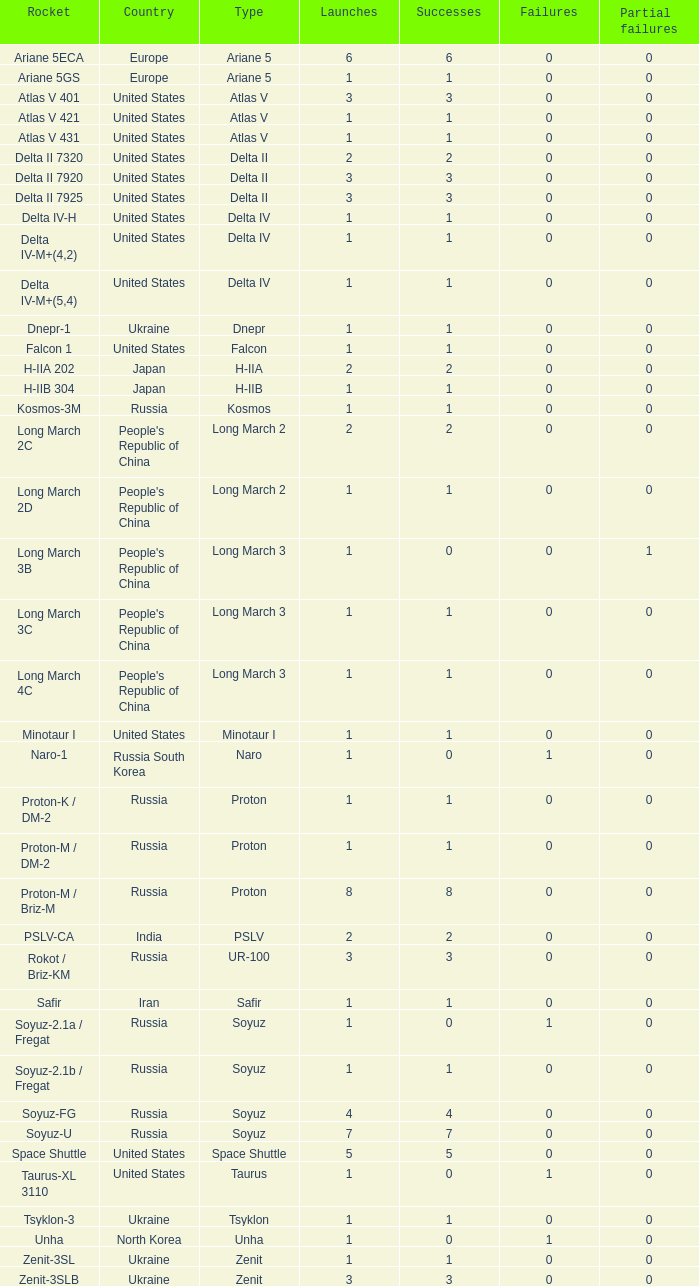What is the quantity of victories for rockets having more than 3 takeoffs, rooted in russia, classified as soyuz and a rocket subtype of soyuz-u? 1.0. 